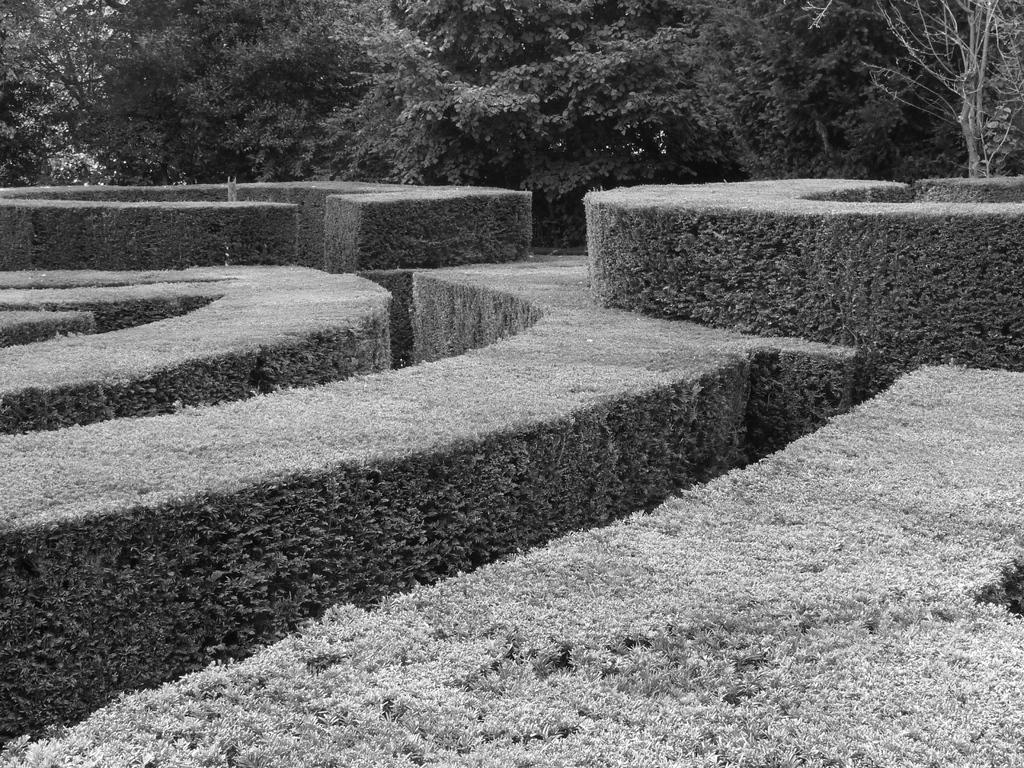Can you describe this image briefly? There is a garden having plants arranged on the ground. In the background, there are trees. 